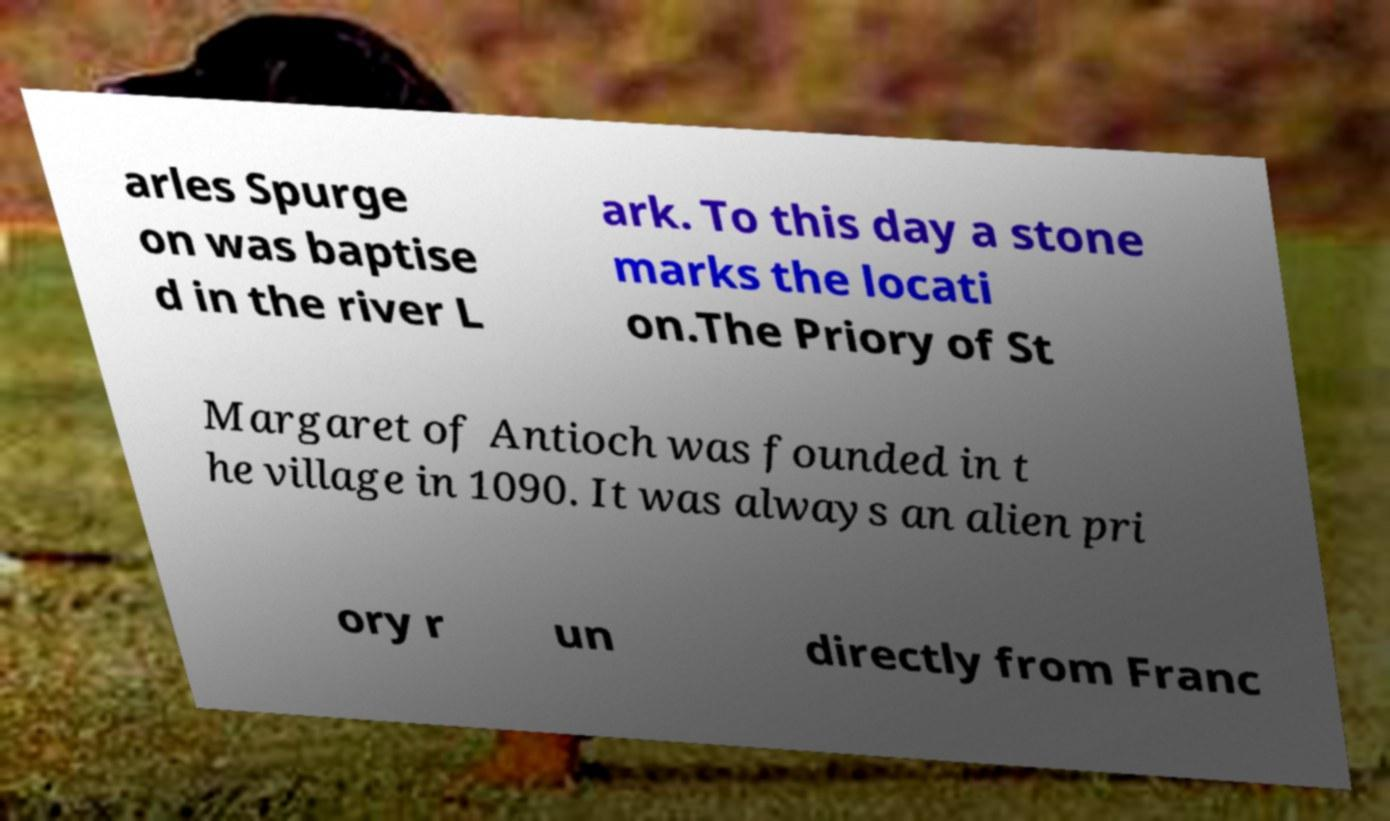Please identify and transcribe the text found in this image. arles Spurge on was baptise d in the river L ark. To this day a stone marks the locati on.The Priory of St Margaret of Antioch was founded in t he village in 1090. It was always an alien pri ory r un directly from Franc 